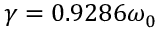Convert formula to latex. <formula><loc_0><loc_0><loc_500><loc_500>\gamma = 0 . 9 2 8 6 \omega _ { 0 }</formula> 